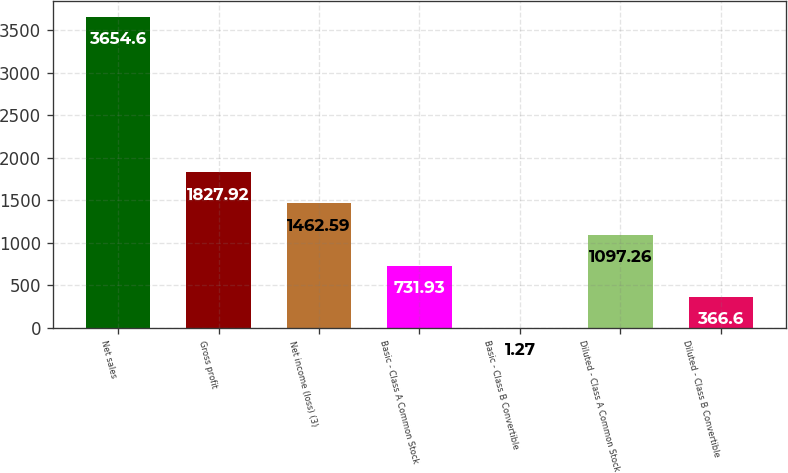Convert chart to OTSL. <chart><loc_0><loc_0><loc_500><loc_500><bar_chart><fcel>Net sales<fcel>Gross profit<fcel>Net income (loss) (3)<fcel>Basic - Class A Common Stock<fcel>Basic - Class B Convertible<fcel>Diluted - Class A Common Stock<fcel>Diluted - Class B Convertible<nl><fcel>3654.6<fcel>1827.92<fcel>1462.59<fcel>731.93<fcel>1.27<fcel>1097.26<fcel>366.6<nl></chart> 